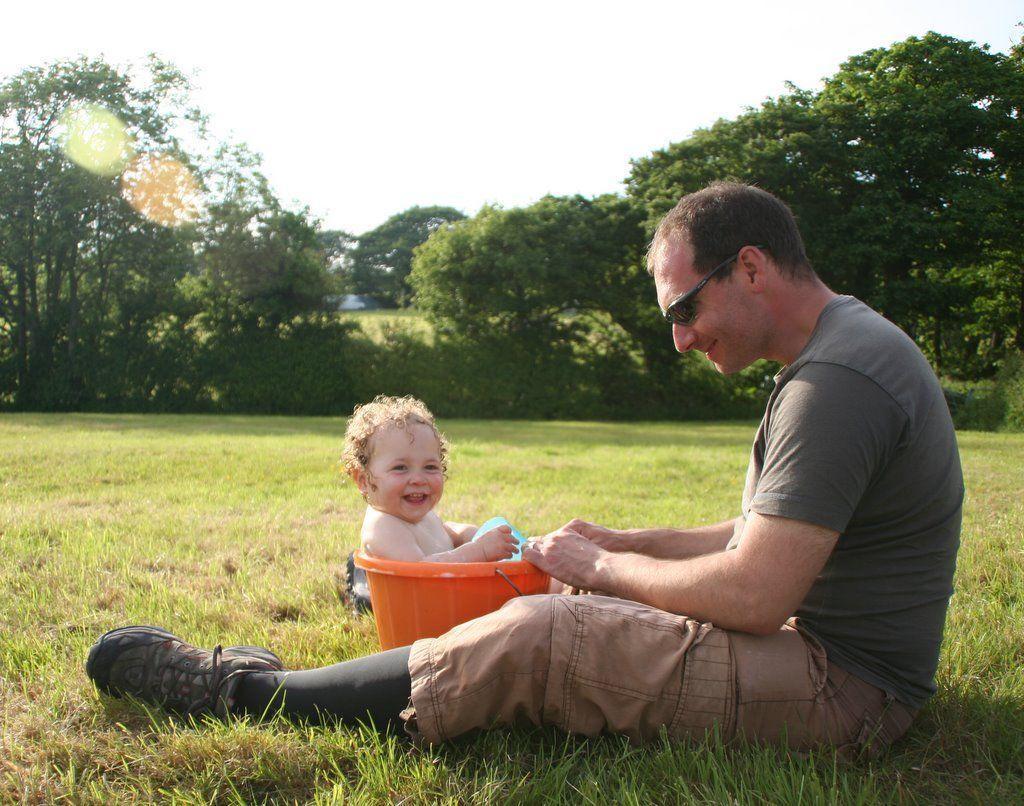Can you describe this image briefly? In this image on the right there is a man he is sitting he wear t shirt, trouser and shades. In the middle there is a child inside the bucket. In the background there are trees, grass and sky. 